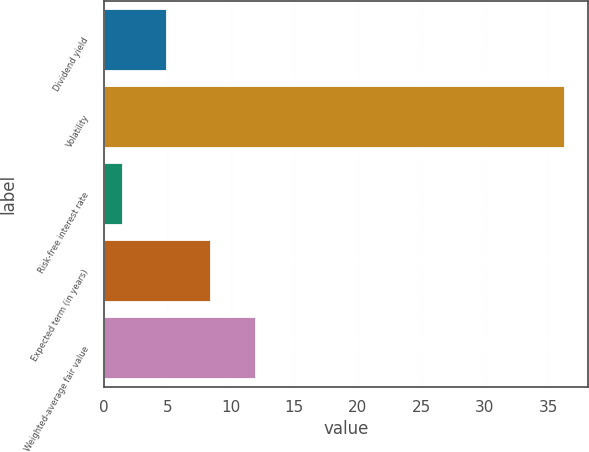Convert chart to OTSL. <chart><loc_0><loc_0><loc_500><loc_500><bar_chart><fcel>Dividend yield<fcel>Volatility<fcel>Risk-free interest rate<fcel>Expected term (in years)<fcel>Weighted-average fair value<nl><fcel>4.98<fcel>36.3<fcel>1.5<fcel>8.46<fcel>11.94<nl></chart> 